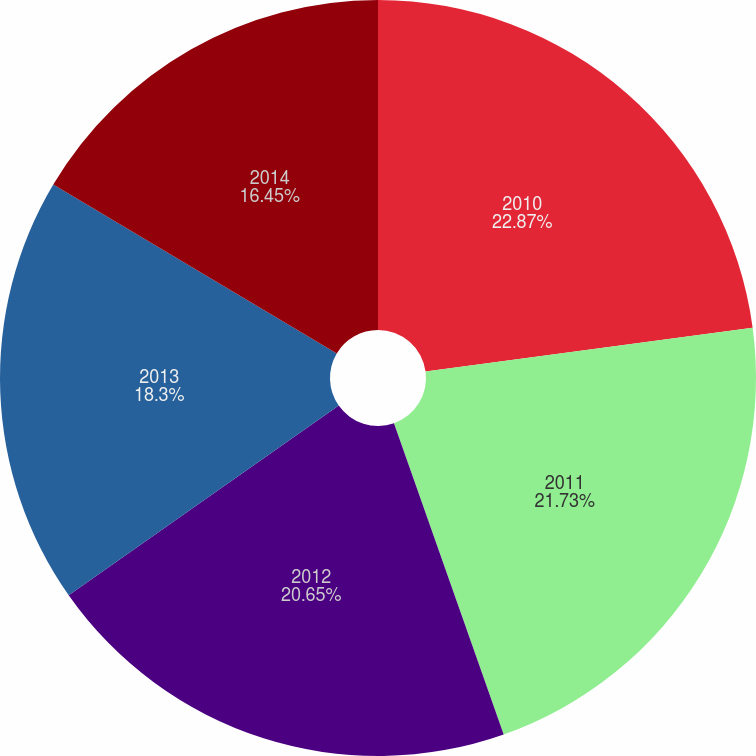<chart> <loc_0><loc_0><loc_500><loc_500><pie_chart><fcel>2010<fcel>2011<fcel>2012<fcel>2013<fcel>2014<nl><fcel>22.88%<fcel>21.73%<fcel>20.65%<fcel>18.3%<fcel>16.45%<nl></chart> 